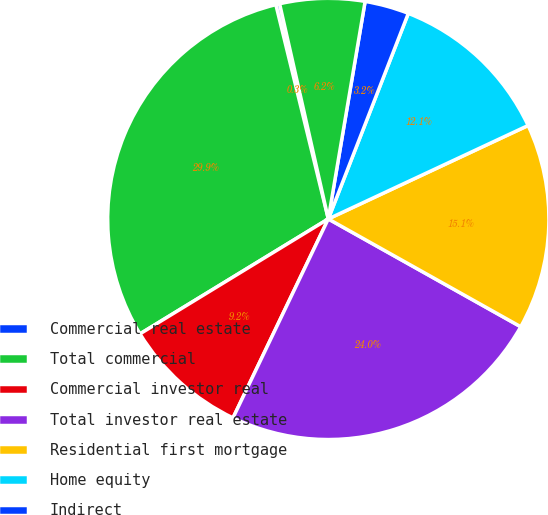Convert chart to OTSL. <chart><loc_0><loc_0><loc_500><loc_500><pie_chart><fcel>Commercial real estate<fcel>Total commercial<fcel>Commercial investor real<fcel>Total investor real estate<fcel>Residential first mortgage<fcel>Home equity<fcel>Indirect<fcel>Other consumer<nl><fcel>0.28%<fcel>29.9%<fcel>9.17%<fcel>23.98%<fcel>15.09%<fcel>12.13%<fcel>3.24%<fcel>6.21%<nl></chart> 